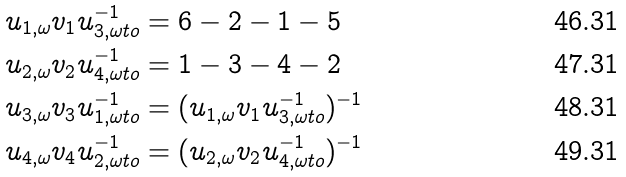Convert formula to latex. <formula><loc_0><loc_0><loc_500><loc_500>u _ { 1 , \omega } v _ { 1 } u _ { 3 , \omega t o } ^ { - 1 } & = 6 - 2 - 1 - 5 \\ u _ { 2 , \omega } v _ { 2 } u _ { 4 , \omega t o } ^ { - 1 } & = 1 - 3 - 4 - 2 \\ u _ { 3 , \omega } v _ { 3 } u _ { 1 , \omega t o } ^ { - 1 } & = ( u _ { 1 , \omega } v _ { 1 } u _ { 3 , \omega t o } ^ { - 1 } ) ^ { - 1 } \\ u _ { 4 , \omega } v _ { 4 } u _ { 2 , \omega t o } ^ { - 1 } & = ( u _ { 2 , \omega } v _ { 2 } u _ { 4 , \omega t o } ^ { - 1 } ) ^ { - 1 }</formula> 